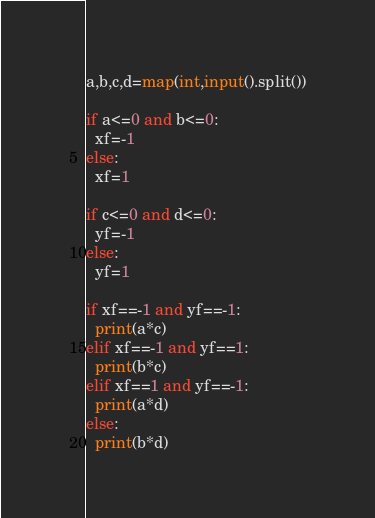<code> <loc_0><loc_0><loc_500><loc_500><_Python_>a,b,c,d=map(int,input().split())

if a<=0 and b<=0:
  xf=-1
else:
  xf=1

if c<=0 and d<=0:
  yf=-1
else:
  yf=1
  
if xf==-1 and yf==-1:
  print(a*c)
elif xf==-1 and yf==1:
  print(b*c)
elif xf==1 and yf==-1:
  print(a*d)
else:
  print(b*d)</code> 